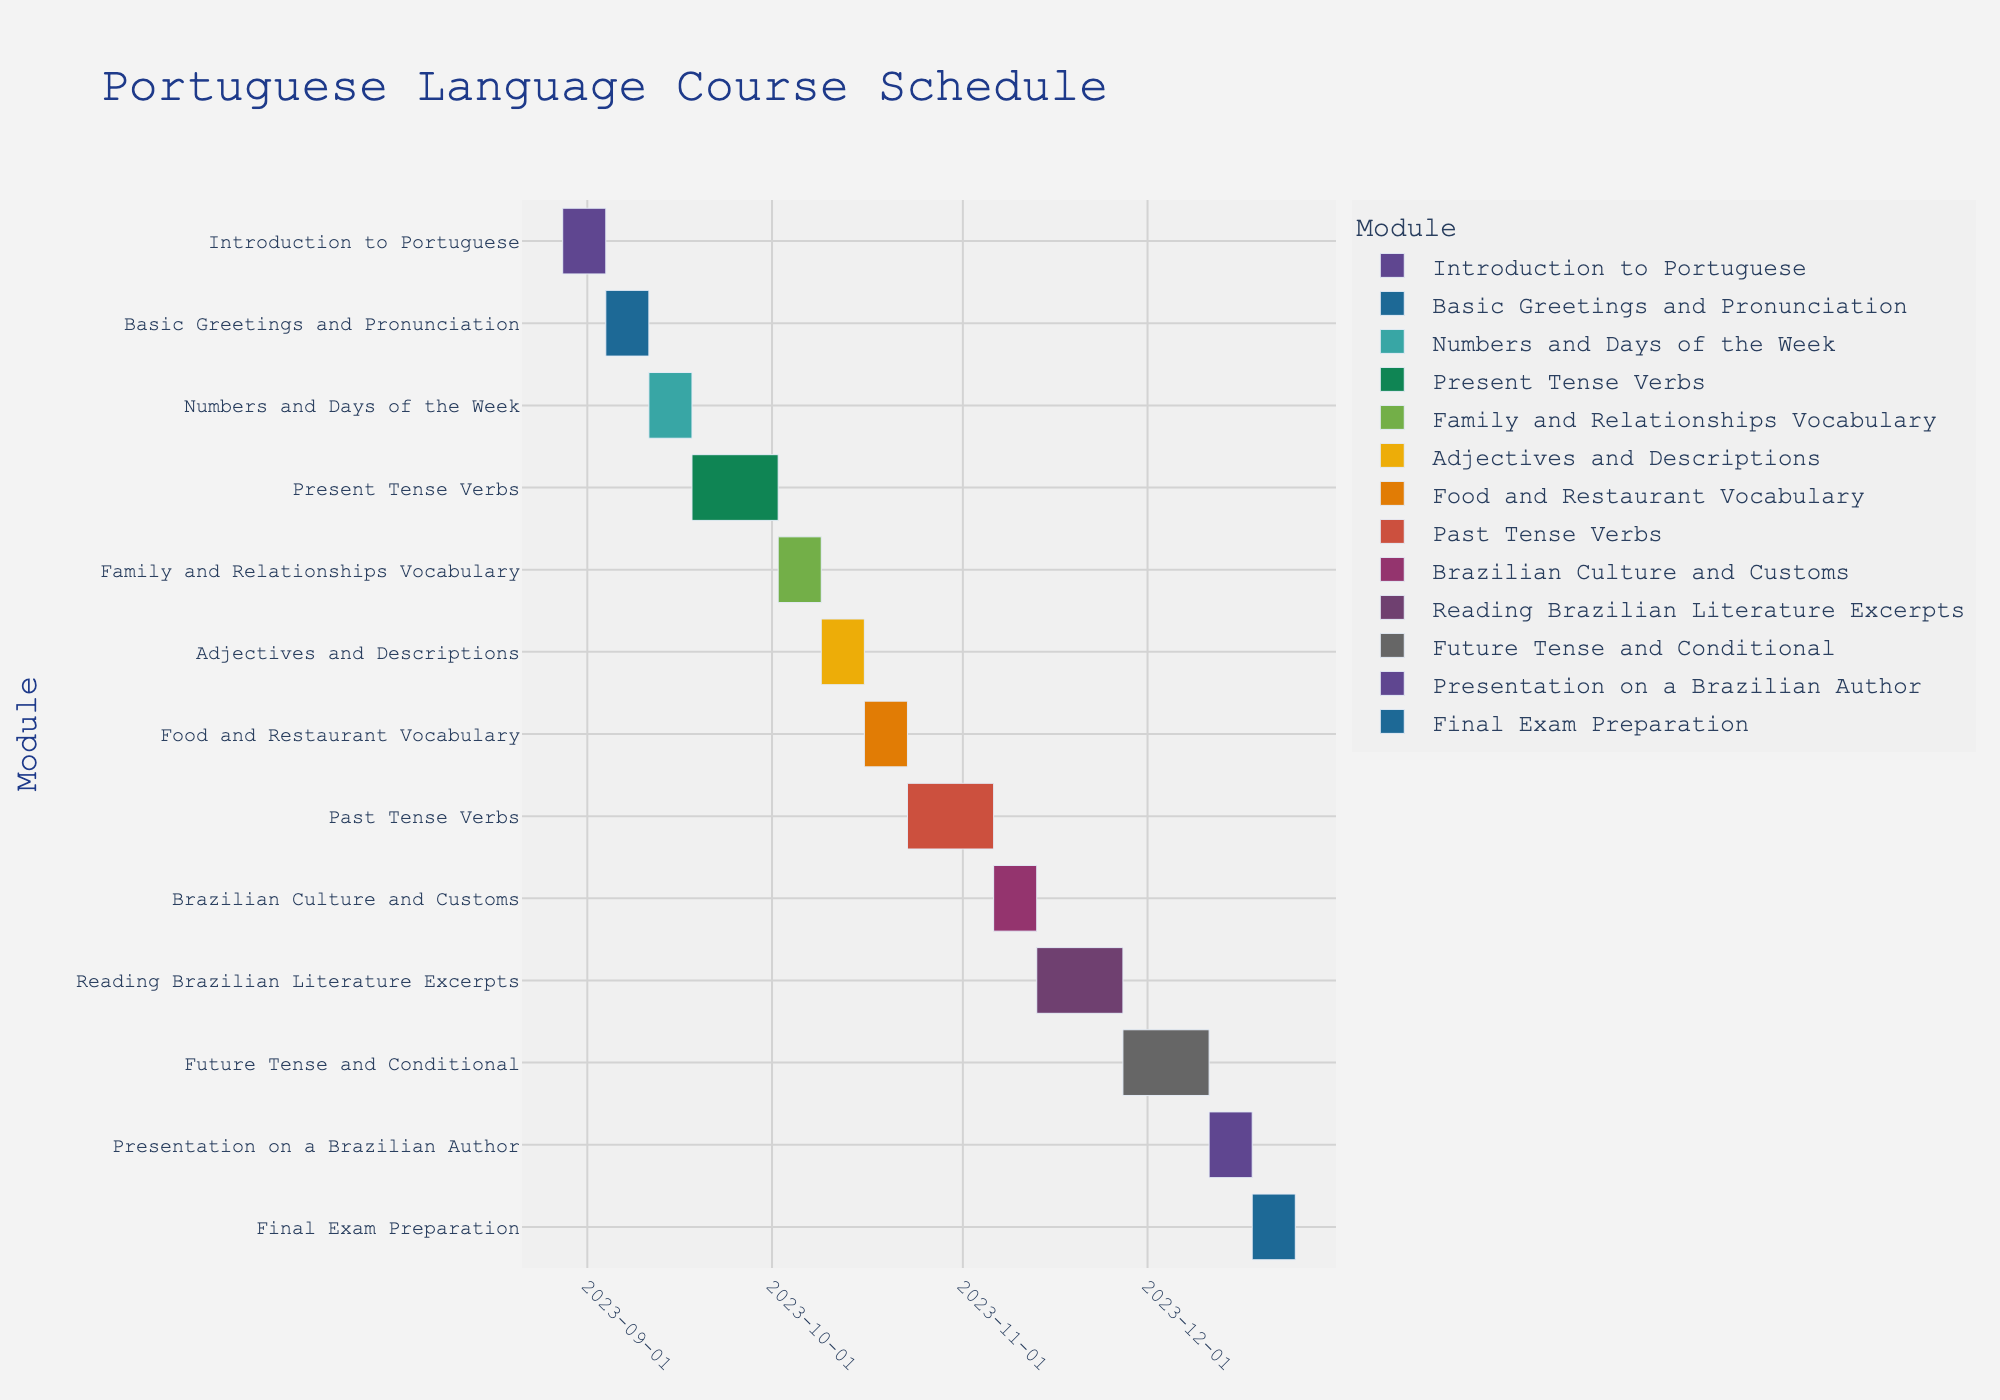What's the title of the Gantt Chart? The title is located at the top of the Gantt Chart, indicating what the chart represents. In this case, it shows the schedule of a Portuguese language course.
Answer: Portuguese Language Course Schedule How long does the "Present Tense Verbs" module last? The duration of each task is indicated by the length of the bar and can be identified by reading the labels. The "Present Tense Verbs" module starts on 2023-09-18 and lasts for 14 days, as indicated in the data.
Answer: 14 days What modules are scheduled to run in October 2023? To determine which modules run in October, look at the date range on the x-axis and the bars that correspond to this time frame. The modules scheduled in October are "Family and Relationships Vocabulary," "Adjectives and Descriptions," "Food and Restaurant Vocabulary," and "Past Tense Verbs."
Answer: Family and Relationships Vocabulary, Adjectives and Descriptions, Food and Restaurant Vocabulary, Past Tense Verbs Which module has the shortest duration and how long is it? By comparing the lengths of the bars representing different modules, you can see which one is shortest. All modules except "Present Tense Verbs," "Past Tense Verbs," "Reading Brazilian Literature Excerpts," and "Future Tense and Conditional" have the shortest duration of 7 days.
Answer: 7 days How many days are covered by the "Past Tense Verbs" and "Future Tense and Conditional" modules together? The duration of both modules can be summed. "Past Tense Verbs" lasts for 14 days and "Future Tense and Conditional" also lasts for 14 days. Adding these together gives 14 + 14.
Answer: 28 days When does the "Reading Brazilian Literature Excerpts" module end? Identifying the end date requires finding the start date and adding the duration. The module starts on 2023-11-13 and lasts for 14 days. Adding 14 days to 2023-11-13 leads to the date 2023-11-27.
Answer: 2023-11-27 How many modules start in November 2023? By examining the start dates along the x-axis, you can count how many modules begin in November. The modules "Brazilian Culture and Customs" (2023-11-06) and "Reading Brazilian Literature Excerpts" (2023-11-13) start in November.
Answer: 2 modules Which module overlaps with "Reading Brazilian Literature Excerpts"? To find overlapping modules, you need to compare the start and end dates of modules. "Future Tense and Conditional" overlaps with "Reading Brazilian Literature Excerpts" as it starts on 2023-11-27, the same date the latter ends.
Answer: Future Tense and Conditional Which module has the longest duration and how long is it? By comparing the lengths of the bars, the module "Present Tense Verbs," "Past Tense Verbs," "Reading Brazilian Literature Excerpts," and "Future Tense and Conditional" each last 14 days. These are the longest durations.
Answer: 14 days 